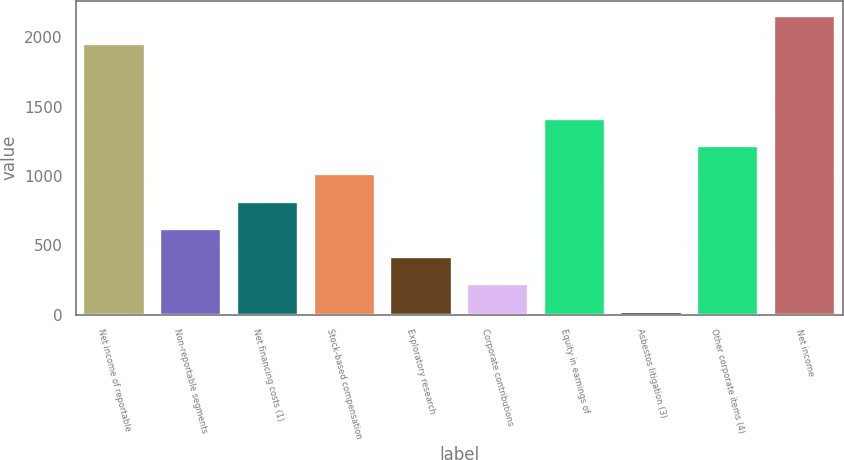<chart> <loc_0><loc_0><loc_500><loc_500><bar_chart><fcel>Net income of reportable<fcel>Non-reportable segments<fcel>Net financing costs (1)<fcel>Stock-based compensation<fcel>Exploratory research<fcel>Corporate contributions<fcel>Equity in earnings of<fcel>Asbestos litigation (3)<fcel>Other corporate items (4)<fcel>Net income<nl><fcel>1954<fcel>616.4<fcel>815.2<fcel>1014<fcel>417.6<fcel>218.8<fcel>1411.6<fcel>20<fcel>1212.8<fcel>2152.8<nl></chart> 